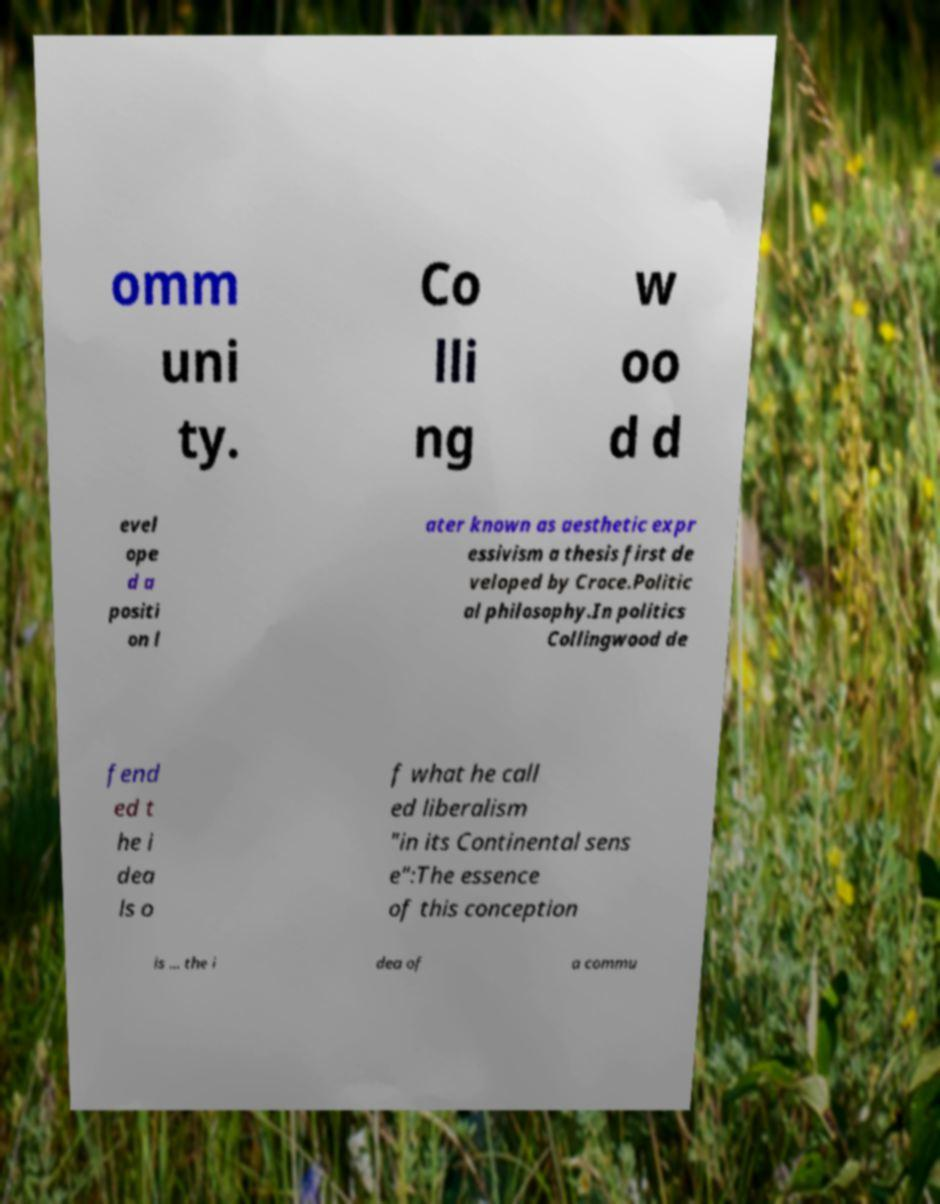What messages or text are displayed in this image? I need them in a readable, typed format. omm uni ty. Co lli ng w oo d d evel ope d a positi on l ater known as aesthetic expr essivism a thesis first de veloped by Croce.Politic al philosophy.In politics Collingwood de fend ed t he i dea ls o f what he call ed liberalism "in its Continental sens e":The essence of this conception is ... the i dea of a commu 